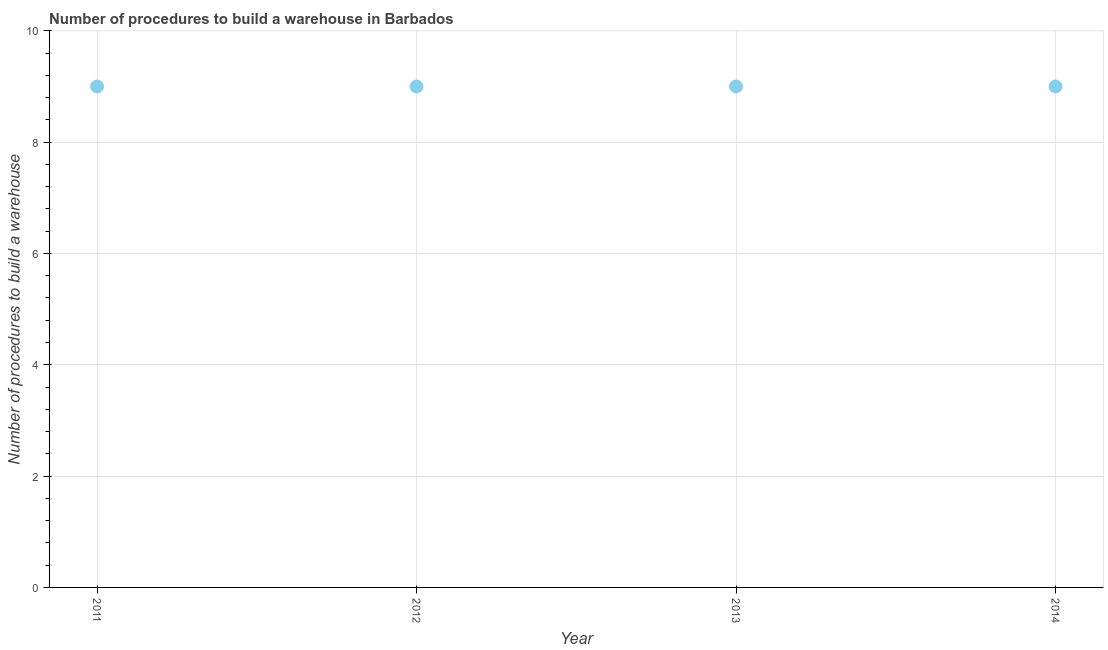What is the number of procedures to build a warehouse in 2012?
Keep it short and to the point. 9. Across all years, what is the maximum number of procedures to build a warehouse?
Provide a short and direct response. 9. Across all years, what is the minimum number of procedures to build a warehouse?
Keep it short and to the point. 9. In which year was the number of procedures to build a warehouse maximum?
Offer a very short reply. 2011. What is the sum of the number of procedures to build a warehouse?
Provide a short and direct response. 36. In how many years, is the number of procedures to build a warehouse greater than 2.8 ?
Your answer should be very brief. 4. What is the ratio of the number of procedures to build a warehouse in 2012 to that in 2013?
Make the answer very short. 1. Is the difference between the number of procedures to build a warehouse in 2011 and 2013 greater than the difference between any two years?
Your answer should be compact. Yes. What is the difference between the highest and the second highest number of procedures to build a warehouse?
Your answer should be very brief. 0. Is the sum of the number of procedures to build a warehouse in 2012 and 2013 greater than the maximum number of procedures to build a warehouse across all years?
Your answer should be very brief. Yes. In how many years, is the number of procedures to build a warehouse greater than the average number of procedures to build a warehouse taken over all years?
Make the answer very short. 0. How many dotlines are there?
Your response must be concise. 1. How many years are there in the graph?
Offer a terse response. 4. Are the values on the major ticks of Y-axis written in scientific E-notation?
Make the answer very short. No. Does the graph contain any zero values?
Give a very brief answer. No. What is the title of the graph?
Provide a succinct answer. Number of procedures to build a warehouse in Barbados. What is the label or title of the X-axis?
Make the answer very short. Year. What is the label or title of the Y-axis?
Your answer should be very brief. Number of procedures to build a warehouse. What is the Number of procedures to build a warehouse in 2011?
Offer a very short reply. 9. What is the Number of procedures to build a warehouse in 2012?
Offer a very short reply. 9. What is the Number of procedures to build a warehouse in 2013?
Your answer should be very brief. 9. What is the difference between the Number of procedures to build a warehouse in 2011 and 2012?
Provide a succinct answer. 0. What is the difference between the Number of procedures to build a warehouse in 2011 and 2014?
Your answer should be compact. 0. What is the difference between the Number of procedures to build a warehouse in 2012 and 2013?
Give a very brief answer. 0. What is the difference between the Number of procedures to build a warehouse in 2012 and 2014?
Keep it short and to the point. 0. What is the difference between the Number of procedures to build a warehouse in 2013 and 2014?
Offer a terse response. 0. What is the ratio of the Number of procedures to build a warehouse in 2011 to that in 2012?
Offer a terse response. 1. What is the ratio of the Number of procedures to build a warehouse in 2011 to that in 2013?
Offer a very short reply. 1. What is the ratio of the Number of procedures to build a warehouse in 2011 to that in 2014?
Make the answer very short. 1. What is the ratio of the Number of procedures to build a warehouse in 2013 to that in 2014?
Your response must be concise. 1. 